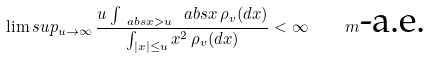<formula> <loc_0><loc_0><loc_500><loc_500>\lim s u p _ { u \to \infty } \, \frac { u \int _ { \ a b s { x } > u } \ a b s { x } \, \rho _ { v } ( d x ) } { \int _ { | x | \leq u } x ^ { 2 } \, \rho _ { v } ( d x ) } < \infty \quad m \text {-a.e.}</formula> 